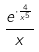<formula> <loc_0><loc_0><loc_500><loc_500>\frac { e ^ { \cdot \frac { 4 } { x ^ { 5 } } } } { x }</formula> 